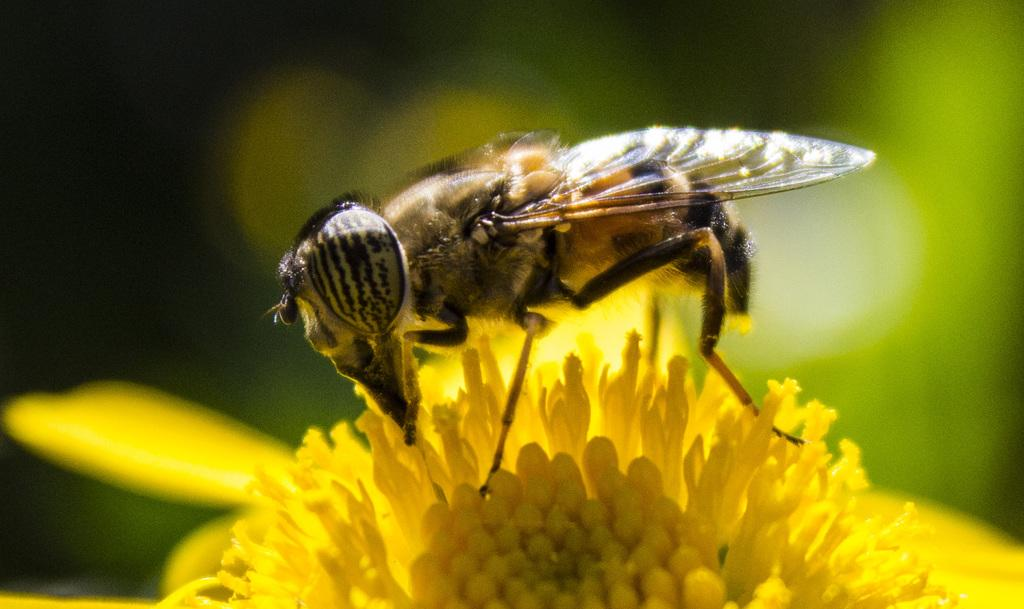What is the main subject of the image? There is an insect in the image. Where is the insect located? The insect is on a flower. Can you describe the background of the image? The background of the image is blurry. What type of stocking is the insect wearing in the image? There is no stocking present in the image, as insects do not wear clothing. 